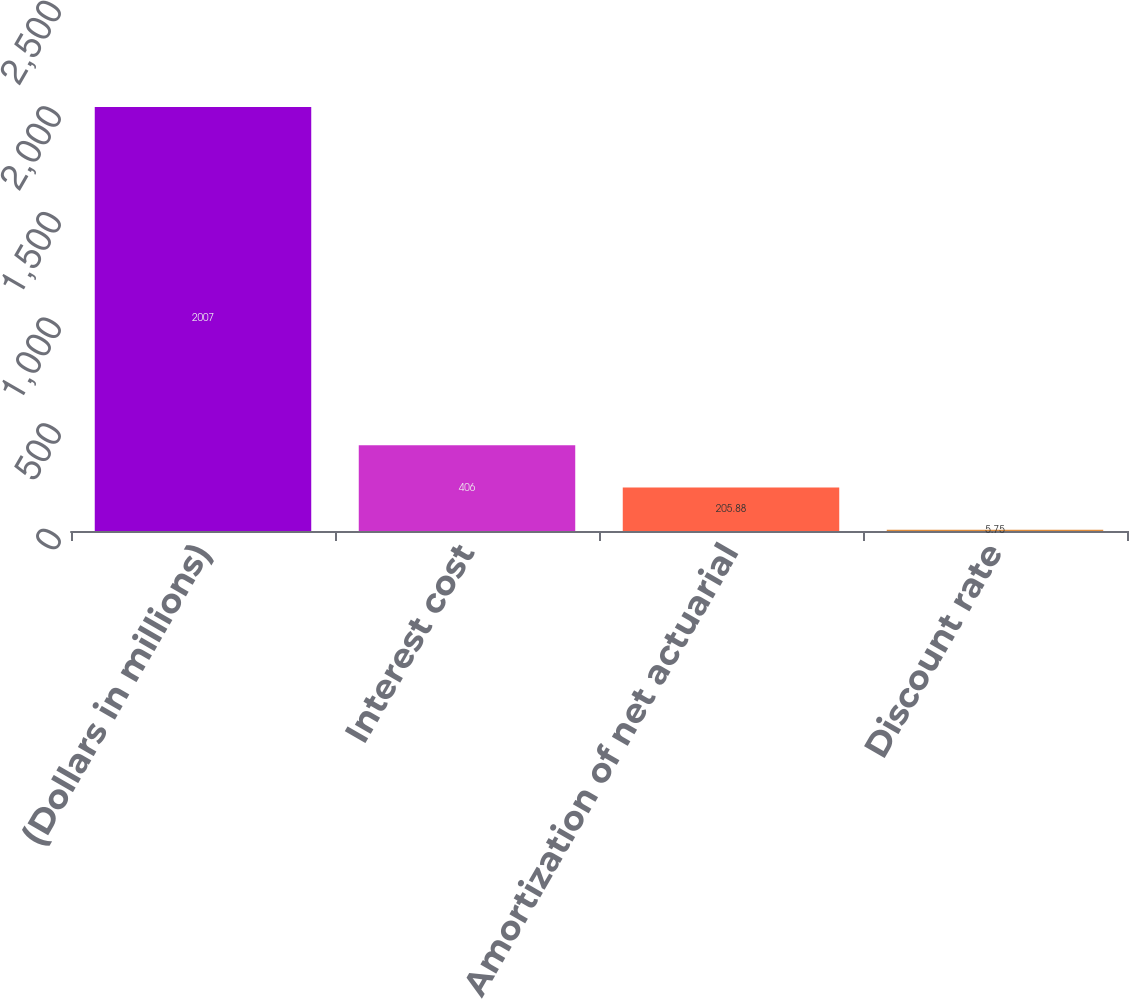<chart> <loc_0><loc_0><loc_500><loc_500><bar_chart><fcel>(Dollars in millions)<fcel>Interest cost<fcel>Amortization of net actuarial<fcel>Discount rate<nl><fcel>2007<fcel>406<fcel>205.88<fcel>5.75<nl></chart> 